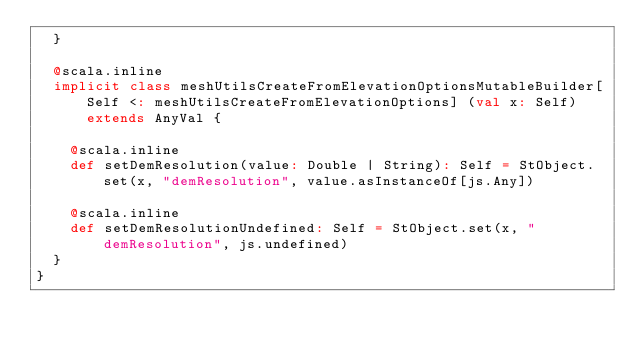Convert code to text. <code><loc_0><loc_0><loc_500><loc_500><_Scala_>  }
  
  @scala.inline
  implicit class meshUtilsCreateFromElevationOptionsMutableBuilder[Self <: meshUtilsCreateFromElevationOptions] (val x: Self) extends AnyVal {
    
    @scala.inline
    def setDemResolution(value: Double | String): Self = StObject.set(x, "demResolution", value.asInstanceOf[js.Any])
    
    @scala.inline
    def setDemResolutionUndefined: Self = StObject.set(x, "demResolution", js.undefined)
  }
}
</code> 